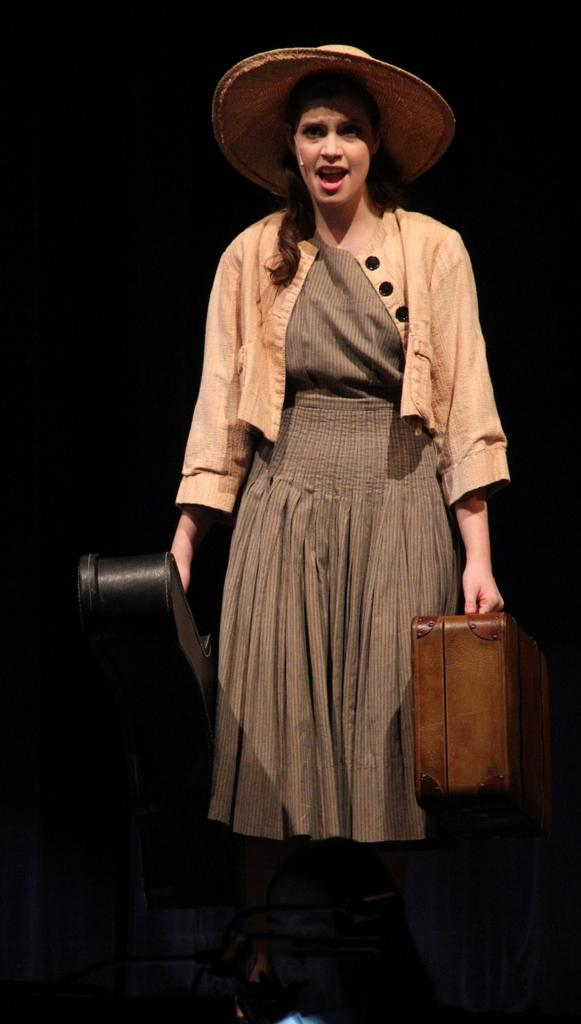What is the main subject of the image? The main subject of the image is a woman. What is the woman wearing? The woman is wearing a top and a skirt, and she is also wearing a hat. What is the woman doing in the image? The woman is singing. What items is the woman holding in the image? The woman is holding a suitcase and a violin bag. What type of animals can be seen at the zoo in the image? There is no zoo or animals present in the image; it features a woman singing while holding a suitcase and a violin bag. What is the woman using to apply cream to her face in the image? There is no cream or application of cream visible in the image. 